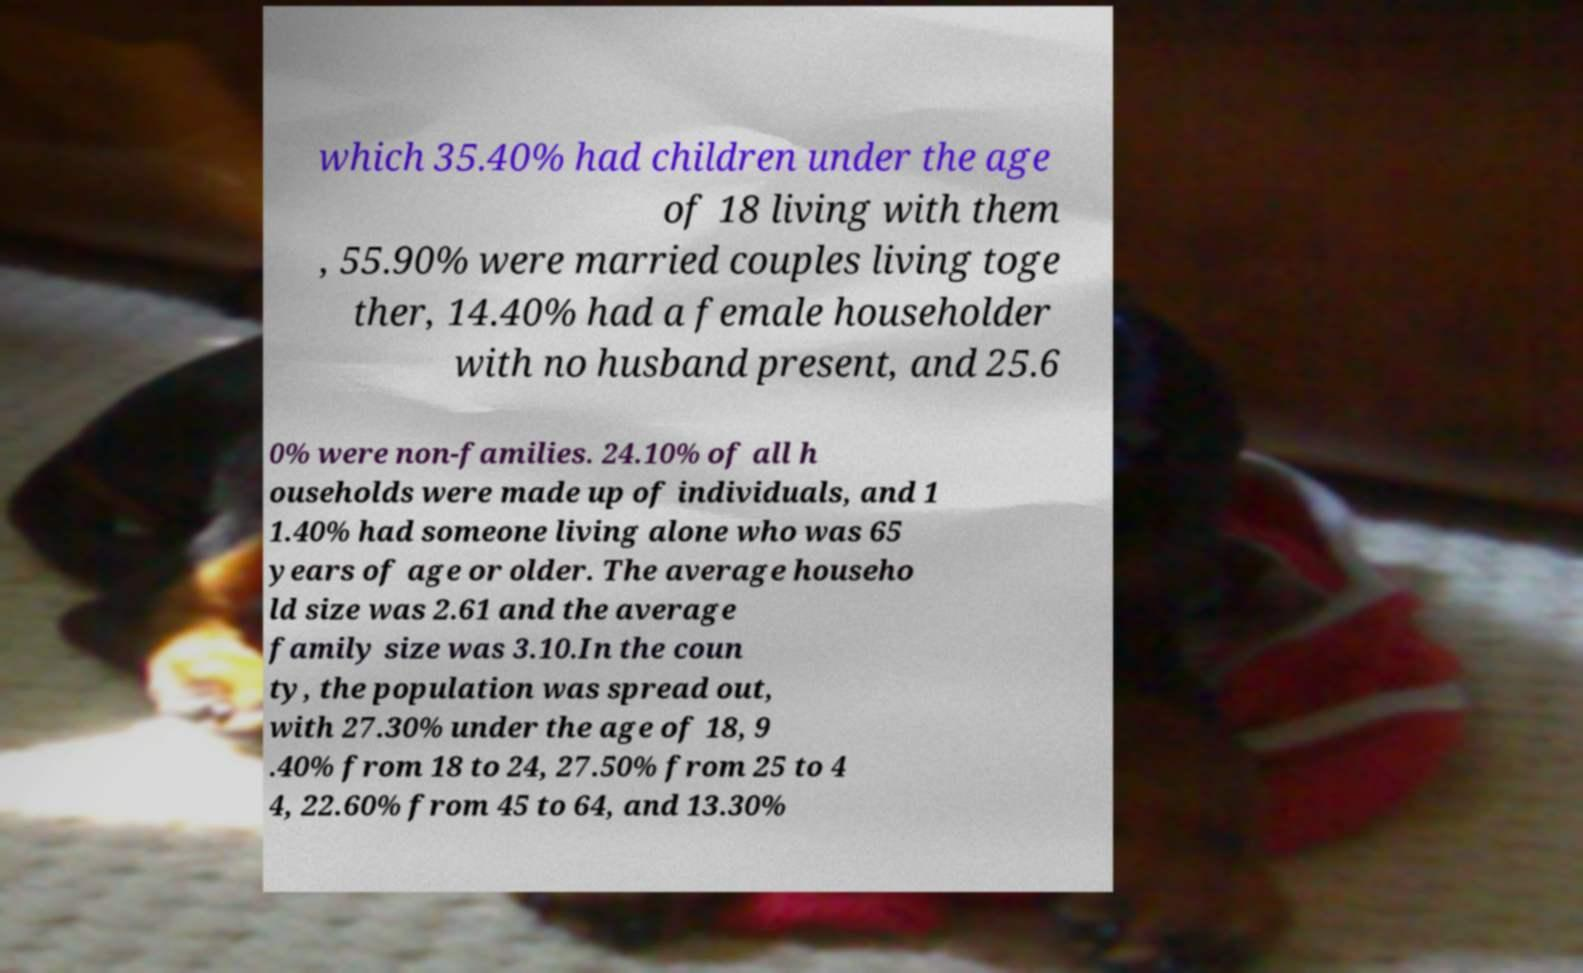There's text embedded in this image that I need extracted. Can you transcribe it verbatim? which 35.40% had children under the age of 18 living with them , 55.90% were married couples living toge ther, 14.40% had a female householder with no husband present, and 25.6 0% were non-families. 24.10% of all h ouseholds were made up of individuals, and 1 1.40% had someone living alone who was 65 years of age or older. The average househo ld size was 2.61 and the average family size was 3.10.In the coun ty, the population was spread out, with 27.30% under the age of 18, 9 .40% from 18 to 24, 27.50% from 25 to 4 4, 22.60% from 45 to 64, and 13.30% 